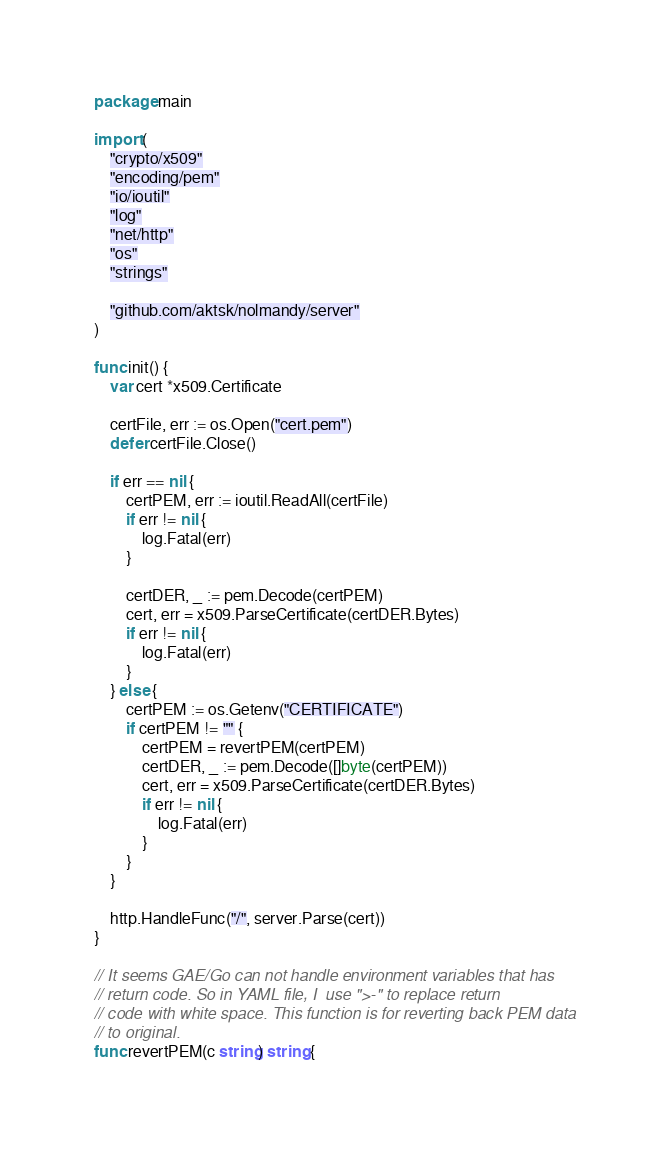<code> <loc_0><loc_0><loc_500><loc_500><_Go_>package main

import (
	"crypto/x509"
	"encoding/pem"
	"io/ioutil"
	"log"
	"net/http"
	"os"
	"strings"

	"github.com/aktsk/nolmandy/server"
)

func init() {
	var cert *x509.Certificate

	certFile, err := os.Open("cert.pem")
	defer certFile.Close()

	if err == nil {
		certPEM, err := ioutil.ReadAll(certFile)
		if err != nil {
			log.Fatal(err)
		}

		certDER, _ := pem.Decode(certPEM)
		cert, err = x509.ParseCertificate(certDER.Bytes)
		if err != nil {
			log.Fatal(err)
		}
	} else {
		certPEM := os.Getenv("CERTIFICATE")
		if certPEM != "" {
			certPEM = revertPEM(certPEM)
			certDER, _ := pem.Decode([]byte(certPEM))
			cert, err = x509.ParseCertificate(certDER.Bytes)
			if err != nil {
				log.Fatal(err)
			}
		}
	}

	http.HandleFunc("/", server.Parse(cert))
}

// It seems GAE/Go can not handle environment variables that has
// return code. So in YAML file, I  use ">-" to replace return
// code with white space. This function is for reverting back PEM data
// to original.
func revertPEM(c string) string {</code> 